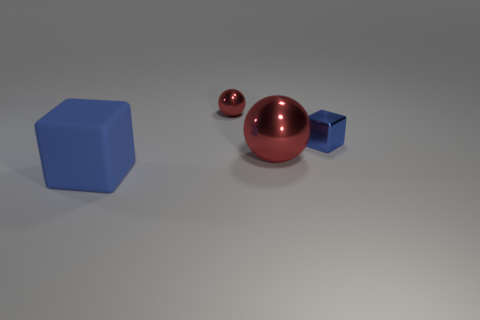Is there anything else that has the same material as the big blue block?
Offer a terse response. No. What is the color of the thing that is both in front of the metallic block and on the right side of the rubber block?
Provide a succinct answer. Red. The red thing that is the same size as the blue rubber block is what shape?
Give a very brief answer. Sphere. Is there another red thing that has the same shape as the matte object?
Give a very brief answer. No. Do the big red object and the red object that is on the left side of the big metallic ball have the same material?
Offer a very short reply. Yes. There is a block to the right of the large object that is to the right of the object left of the small metallic ball; what color is it?
Provide a short and direct response. Blue. What is the material of the other thing that is the same size as the blue metal thing?
Provide a short and direct response. Metal. What number of tiny things are the same material as the large ball?
Offer a very short reply. 2. Is the size of the red thing that is to the left of the large red metal ball the same as the block on the right side of the blue rubber thing?
Make the answer very short. Yes. There is a large shiny ball behind the matte block; what color is it?
Your answer should be very brief. Red. 